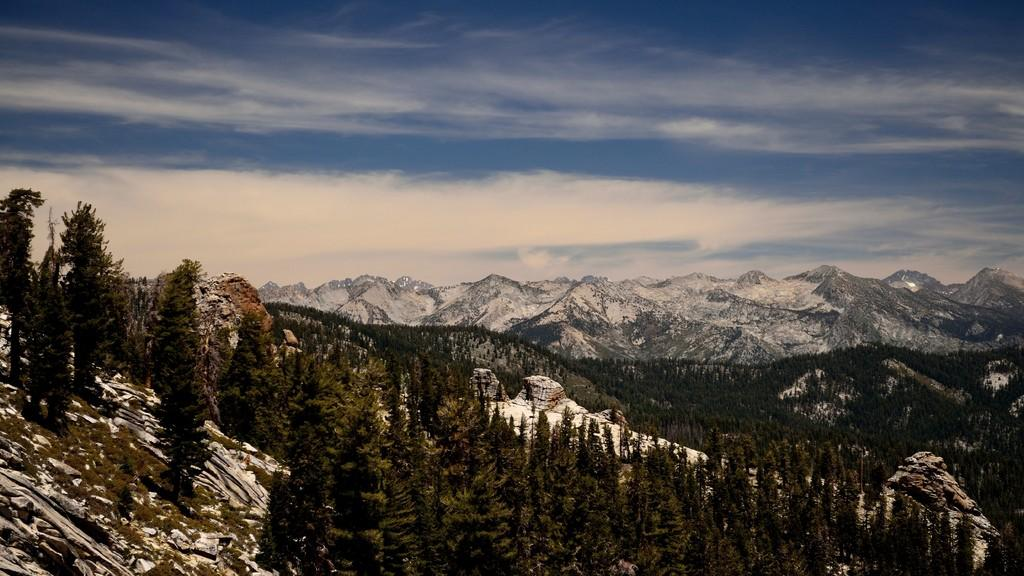What type of natural environment is depicted in the image? The image features many trees and mountains, indicating a natural environment. Can you describe the sky in the image? The sky is visible at the top of the image. What type of ant can be seen teaching a class of celery in the image? There are no ants or celery present in the image, and therefore no such activity can be observed. 